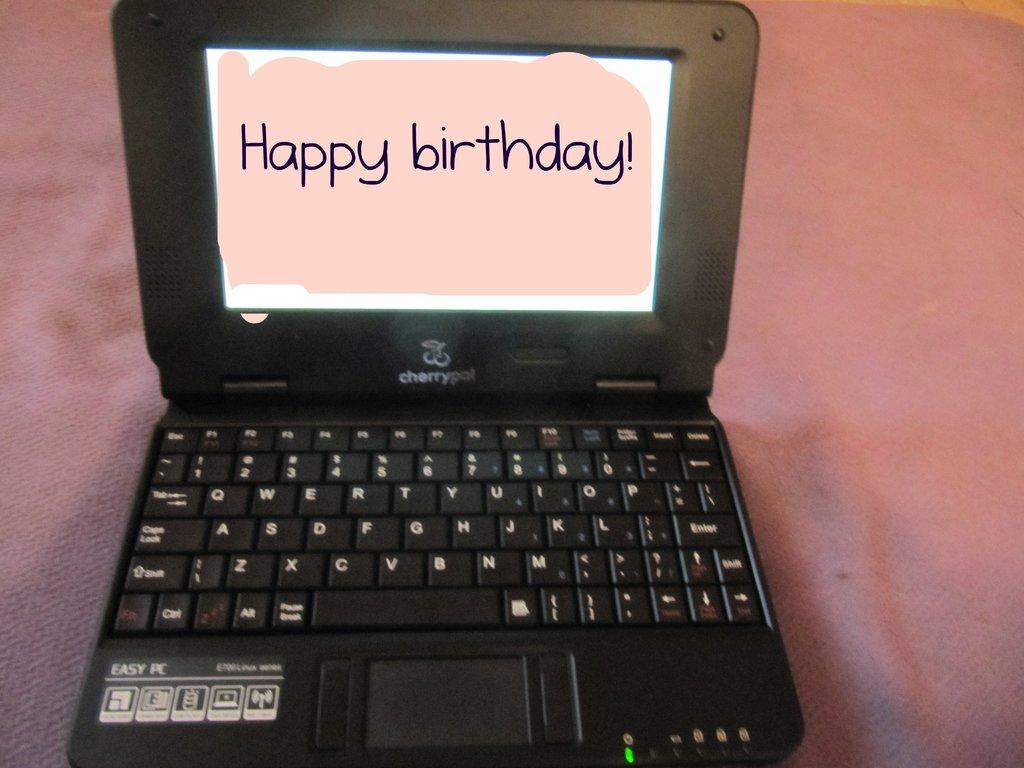<image>
Offer a succinct explanation of the picture presented. A Cherry Pal laptop is open and has Happy Birthday! on its screen. 